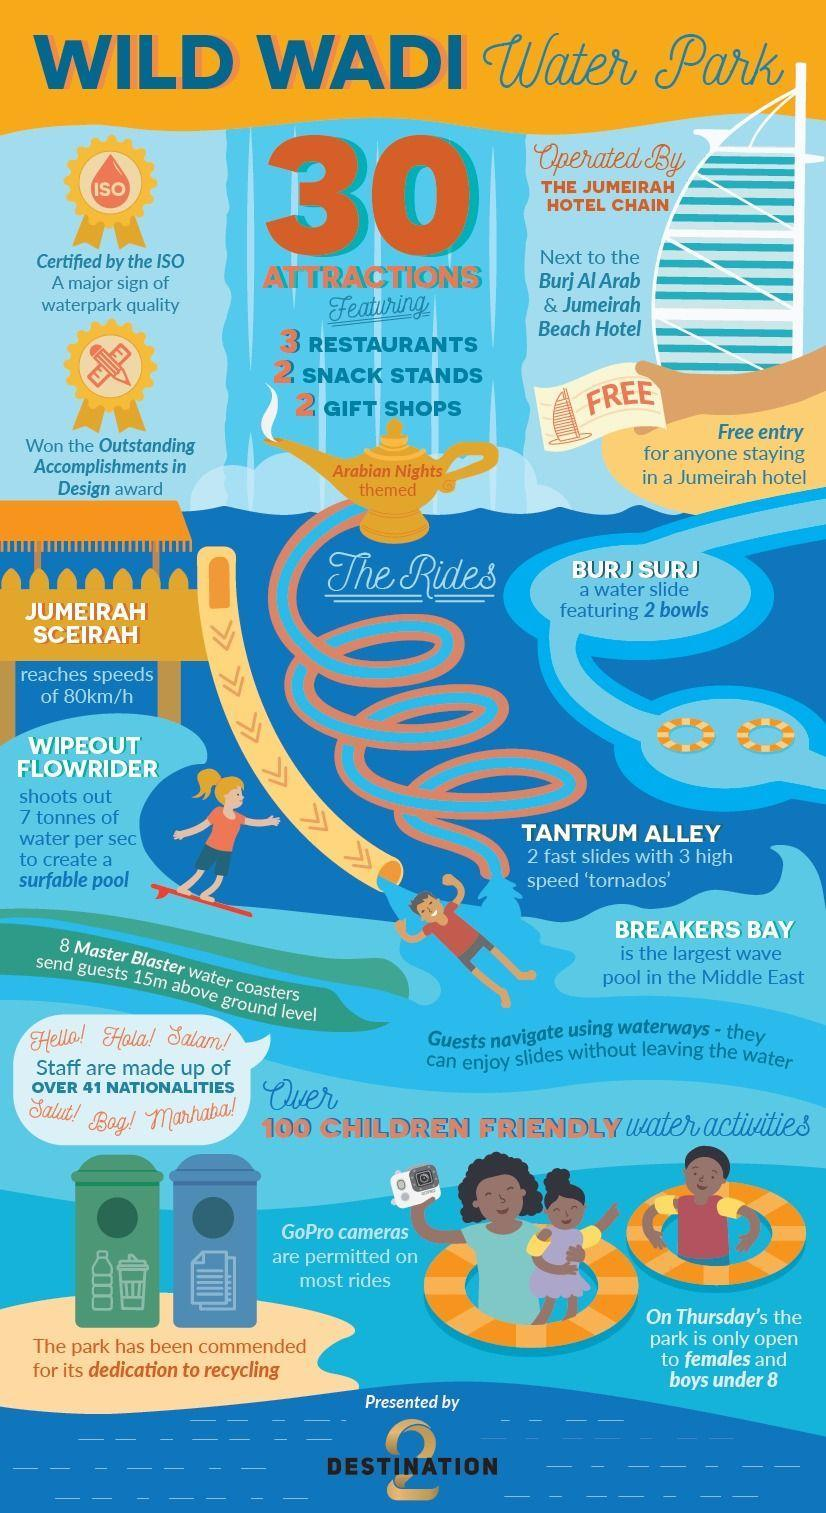What are adjacent to Wild Wadi Water Park
Answer the question with a short phrase. Burj AlArab & Jumeirah Beach Hotel what is written on the lamp Arabian Nights themed Which ride has 2 bowls Burj Surj Where is the largest wave pool in the middle east Wild wadi water park what is Marhaba in English Hello What creates a surfable pool Wipeout Flowrider 